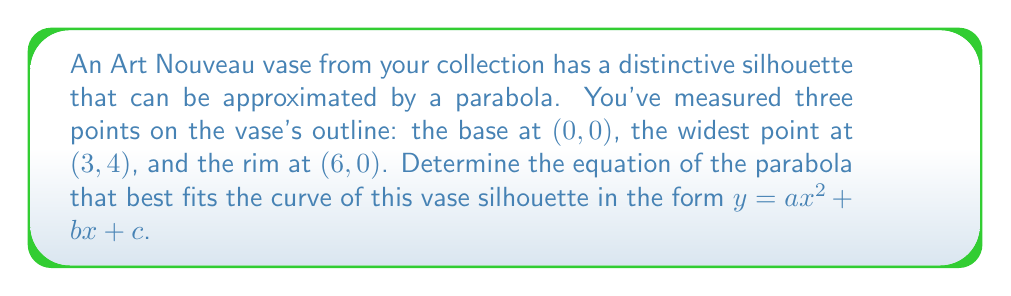Could you help me with this problem? To find the equation of the parabola, we'll use the general form $y = ax^2 + bx + c$ and the three given points to create a system of equations:

1) For (0, 0): $0 = a(0)^2 + b(0) + c$, which simplifies to $c = 0$

2) For (3, 4): $4 = a(3)^2 + b(3) + 0$, or $4 = 9a + 3b$

3) For (6, 0): $0 = a(6)^2 + b(6) + 0$, or $0 = 36a + 6b$

Now we have a system of two equations with two unknowns:
$$
\begin{cases}
4 = 9a + 3b \\
0 = 36a + 6b
\end{cases}
$$

Multiply the first equation by 4 and the second by -1:
$$
\begin{cases}
16 = 36a + 12b \\
0 = -36a - 6b
\end{cases}
$$

Add these equations:
$16 = 6b$

Solve for $b$:
$b = \frac{16}{6} = \frac{8}{3}$

Substitute this value of $b$ into the equation $0 = 36a + 6b$:
$$
\begin{align}
0 &= 36a + 6(\frac{8}{3}) \\
0 &= 36a + 16 \\
-16 &= 36a \\
a &= -\frac{4}{9}
\end{align}
$$

Therefore, the equation of the parabola is:

$y = -\frac{4}{9}x^2 + \frac{8}{3}x + 0$
Answer: $y = -\frac{4}{9}x^2 + \frac{8}{3}x$ 